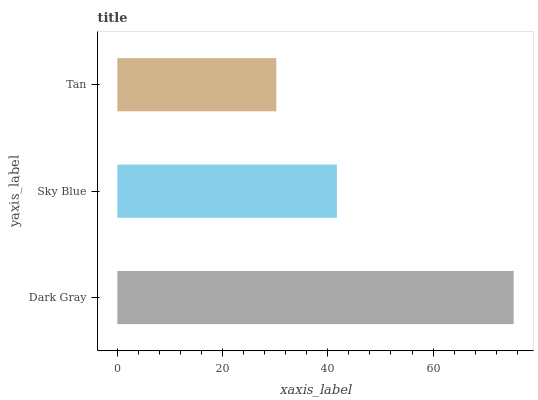Is Tan the minimum?
Answer yes or no. Yes. Is Dark Gray the maximum?
Answer yes or no. Yes. Is Sky Blue the minimum?
Answer yes or no. No. Is Sky Blue the maximum?
Answer yes or no. No. Is Dark Gray greater than Sky Blue?
Answer yes or no. Yes. Is Sky Blue less than Dark Gray?
Answer yes or no. Yes. Is Sky Blue greater than Dark Gray?
Answer yes or no. No. Is Dark Gray less than Sky Blue?
Answer yes or no. No. Is Sky Blue the high median?
Answer yes or no. Yes. Is Sky Blue the low median?
Answer yes or no. Yes. Is Dark Gray the high median?
Answer yes or no. No. Is Tan the low median?
Answer yes or no. No. 